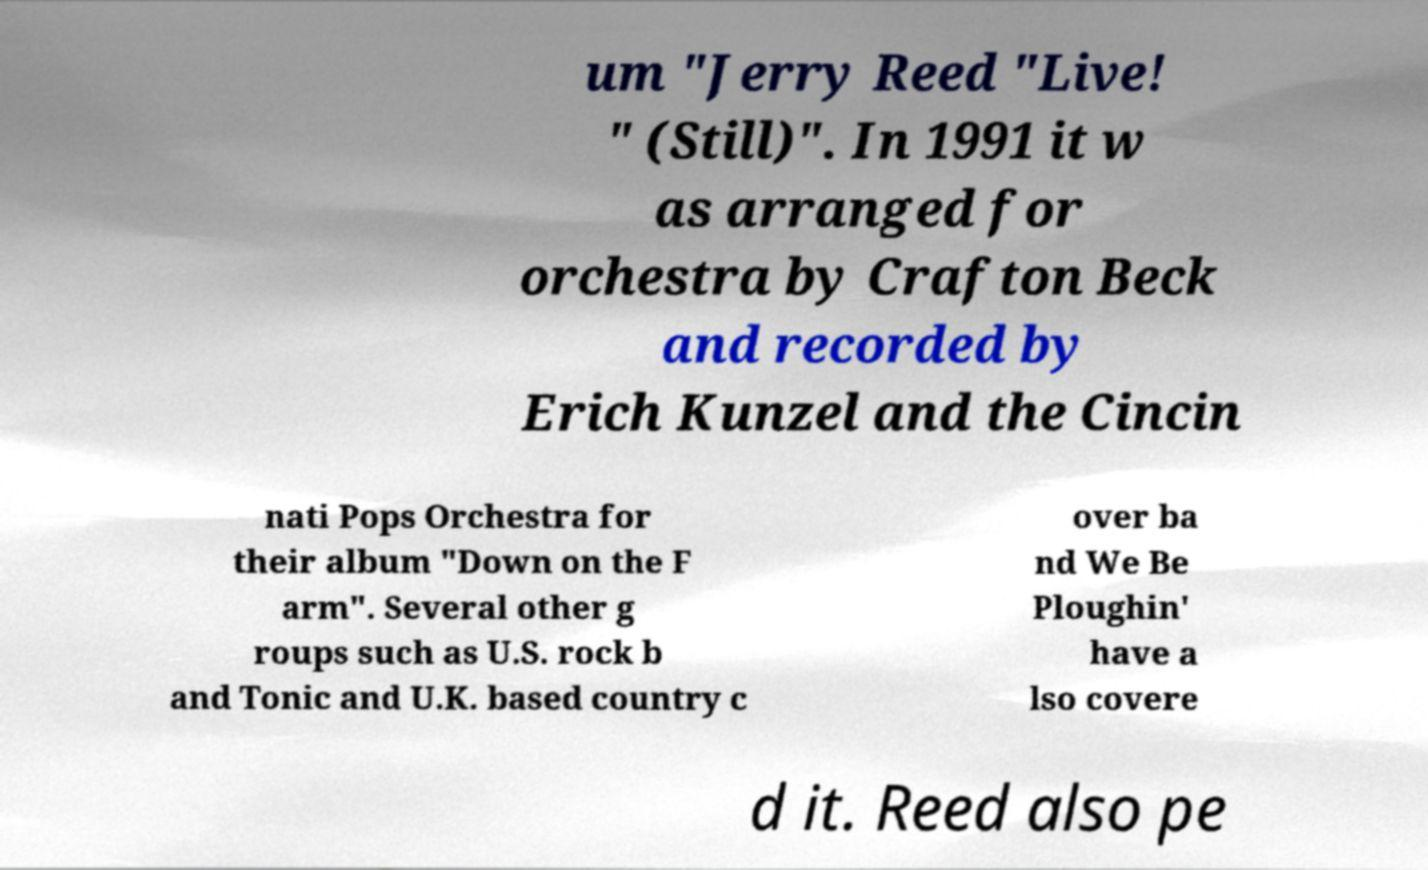What messages or text are displayed in this image? I need them in a readable, typed format. um "Jerry Reed "Live! " (Still)". In 1991 it w as arranged for orchestra by Crafton Beck and recorded by Erich Kunzel and the Cincin nati Pops Orchestra for their album "Down on the F arm". Several other g roups such as U.S. rock b and Tonic and U.K. based country c over ba nd We Be Ploughin' have a lso covere d it. Reed also pe 